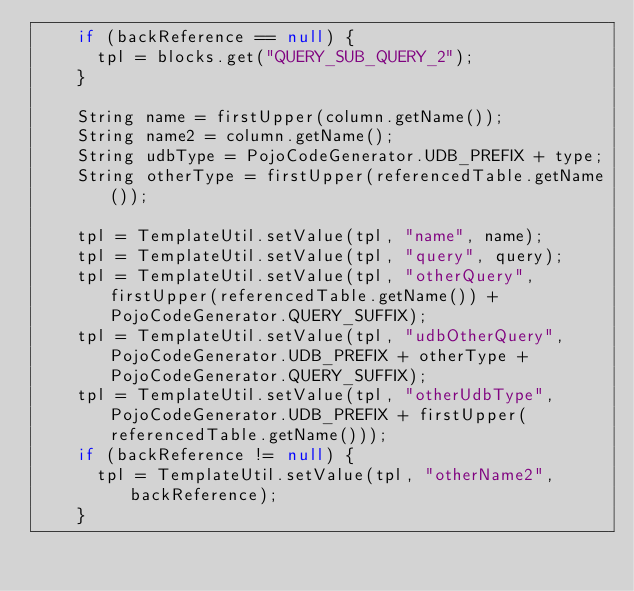Convert code to text. <code><loc_0><loc_0><loc_500><loc_500><_Java_>		if (backReference == null) {
			tpl = blocks.get("QUERY_SUB_QUERY_2");
		}

		String name = firstUpper(column.getName());
		String name2 = column.getName();
		String udbType = PojoCodeGenerator.UDB_PREFIX + type;
		String otherType = firstUpper(referencedTable.getName());

		tpl = TemplateUtil.setValue(tpl, "name", name);
		tpl = TemplateUtil.setValue(tpl, "query", query);
		tpl = TemplateUtil.setValue(tpl, "otherQuery", firstUpper(referencedTable.getName()) + PojoCodeGenerator.QUERY_SUFFIX);
		tpl = TemplateUtil.setValue(tpl, "udbOtherQuery", PojoCodeGenerator.UDB_PREFIX + otherType + PojoCodeGenerator.QUERY_SUFFIX);
		tpl = TemplateUtil.setValue(tpl, "otherUdbType", PojoCodeGenerator.UDB_PREFIX + firstUpper(referencedTable.getName()));
		if (backReference != null) {
			tpl = TemplateUtil.setValue(tpl, "otherName2", backReference);
		}</code> 